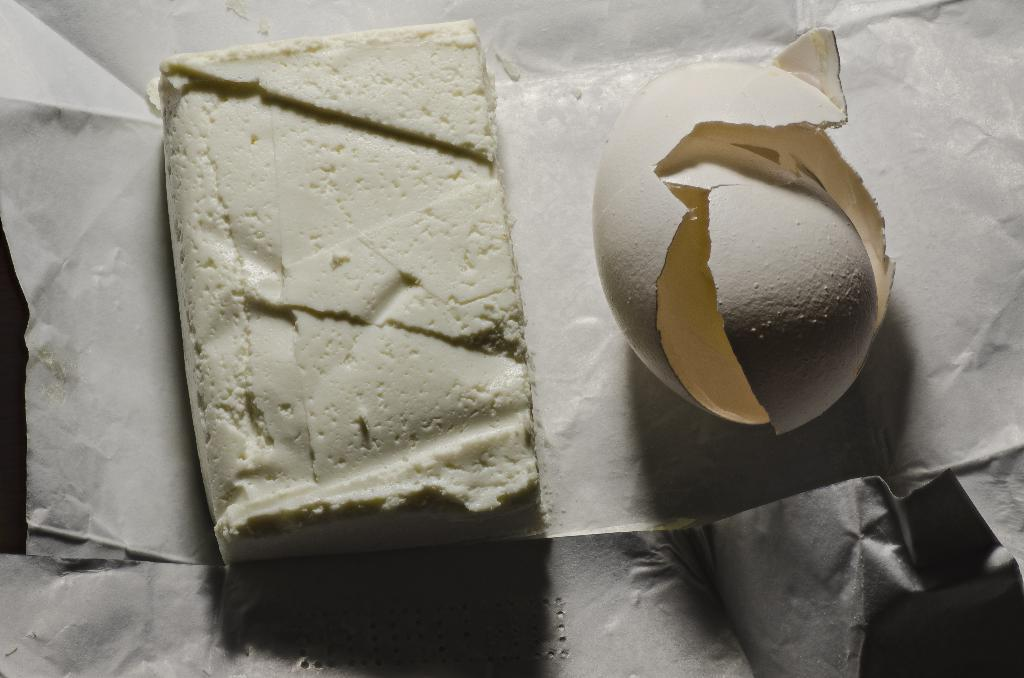What can be seen in the image that is related to eggs? There are egg shells in the image. What is the food item placed on in the image? The food item is placed on a white paper in the image. What type of animal can be seen performing an observation in the image? There is no animal present in the image, and no observation is being performed. 